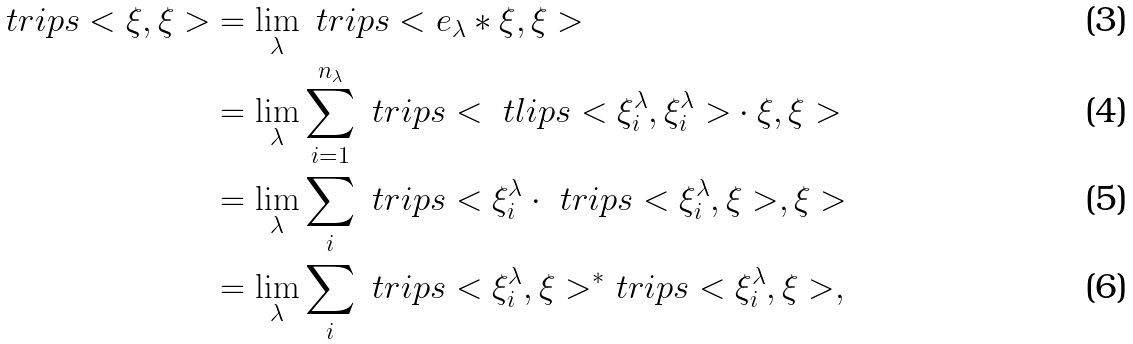<formula> <loc_0><loc_0><loc_500><loc_500>\ t r i p s < \xi , \xi > & = \lim _ { \lambda } \ t r i p s < e _ { \lambda } * \xi , \xi > \\ & = \lim _ { \lambda } \sum _ { i = 1 } ^ { n _ { \lambda } } \ t r i p s < { \ t l i p s < \xi _ { i } ^ { \lambda } , \xi _ { i } ^ { \lambda } > } \cdot \xi , \xi > \\ & = \lim _ { \lambda } \sum _ { i } \ t r i p s < \xi _ { i } ^ { \lambda } \cdot { \ t r i p s < \xi _ { i } ^ { \lambda } , \xi > } , \xi > \\ & = \lim _ { \lambda } \sum _ { i } { \ t r i p s < \xi _ { i } ^ { \lambda } , \xi > ^ { * } } \ t r i p s < \xi _ { i } ^ { \lambda } , \xi > ,</formula> 